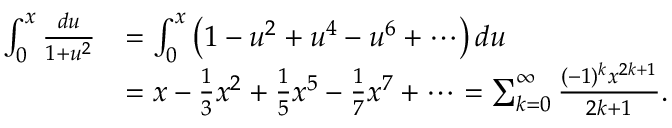Convert formula to latex. <formula><loc_0><loc_0><loc_500><loc_500>{ \begin{array} { r l } { \int _ { 0 } ^ { x } { \frac { d u } { 1 + u ^ { 2 } } } } & { = \int _ { 0 } ^ { x } \left ( 1 - u ^ { 2 } + u ^ { 4 } - u ^ { 6 } + \cdots \right ) d u } \\ & { = x - { \frac { 1 } { 3 } } x ^ { 2 } + { \frac { 1 } { 5 } } x ^ { 5 } - { \frac { 1 } { 7 } } x ^ { 7 } + \cdots = \sum _ { k = 0 } ^ { \infty } { \frac { ( - 1 ) ^ { k } x ^ { 2 k + 1 } } { 2 k + 1 } } . } \end{array} }</formula> 